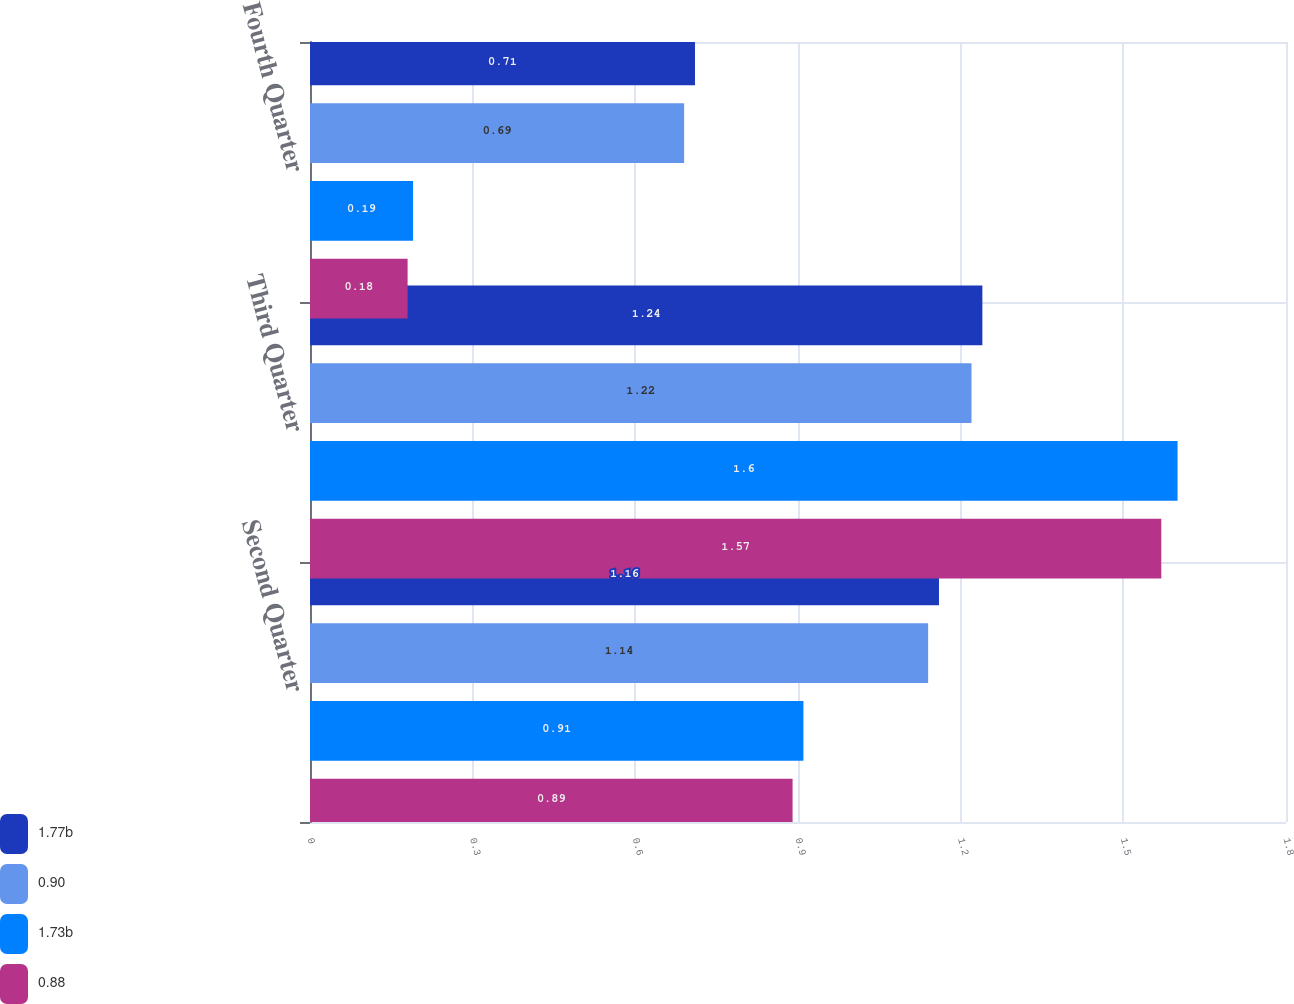Convert chart to OTSL. <chart><loc_0><loc_0><loc_500><loc_500><stacked_bar_chart><ecel><fcel>Second Quarter<fcel>Third Quarter<fcel>Fourth Quarter<nl><fcel>1.77b<fcel>1.16<fcel>1.24<fcel>0.71<nl><fcel>0.90<fcel>1.14<fcel>1.22<fcel>0.69<nl><fcel>1.73b<fcel>0.91<fcel>1.6<fcel>0.19<nl><fcel>0.88<fcel>0.89<fcel>1.57<fcel>0.18<nl></chart> 